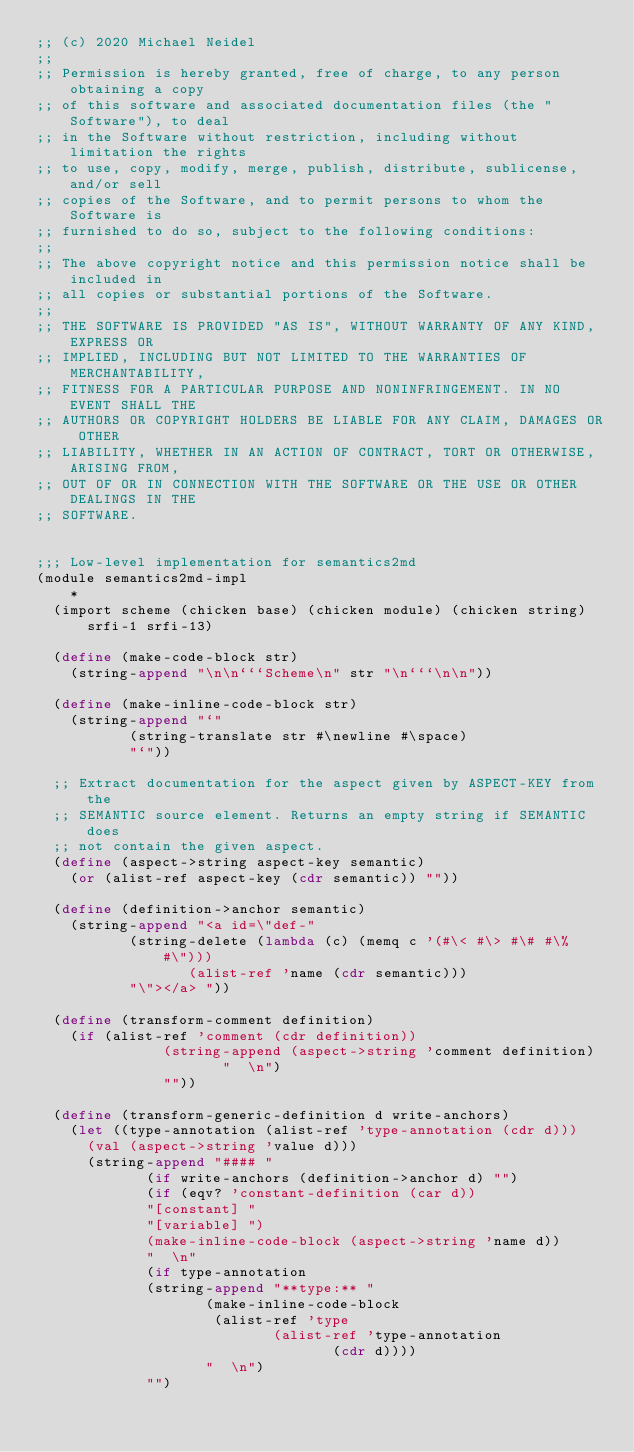<code> <loc_0><loc_0><loc_500><loc_500><_Scheme_>;; (c) 2020 Michael Neidel
;;
;; Permission is hereby granted, free of charge, to any person obtaining a copy
;; of this software and associated documentation files (the "Software"), to deal
;; in the Software without restriction, including without limitation the rights
;; to use, copy, modify, merge, publish, distribute, sublicense, and/or sell
;; copies of the Software, and to permit persons to whom the Software is
;; furnished to do so, subject to the following conditions:
;;
;; The above copyright notice and this permission notice shall be included in
;; all copies or substantial portions of the Software.
;;
;; THE SOFTWARE IS PROVIDED "AS IS", WITHOUT WARRANTY OF ANY KIND, EXPRESS OR
;; IMPLIED, INCLUDING BUT NOT LIMITED TO THE WARRANTIES OF MERCHANTABILITY,
;; FITNESS FOR A PARTICULAR PURPOSE AND NONINFRINGEMENT. IN NO EVENT SHALL THE
;; AUTHORS OR COPYRIGHT HOLDERS BE LIABLE FOR ANY CLAIM, DAMAGES OR OTHER
;; LIABILITY, WHETHER IN AN ACTION OF CONTRACT, TORT OR OTHERWISE, ARISING FROM,
;; OUT OF OR IN CONNECTION WITH THE SOFTWARE OR THE USE OR OTHER DEALINGS IN THE
;; SOFTWARE.


;;; Low-level implementation for semantics2md
(module semantics2md-impl
    *
  (import scheme (chicken base) (chicken module) (chicken string)
	  srfi-1 srfi-13)

  (define (make-code-block str)
    (string-append "\n\n```Scheme\n" str "\n```\n\n"))

  (define (make-inline-code-block str)
    (string-append "`"
		   (string-translate str #\newline #\space)
		   "`"))

  ;; Extract documentation for the aspect given by ASPECT-KEY from the
  ;; SEMANTIC source element. Returns an empty string if SEMANTIC does
  ;; not contain the given aspect.
  (define (aspect->string aspect-key semantic)
    (or (alist-ref aspect-key (cdr semantic)) ""))

  (define (definition->anchor semantic)
    (string-append "<a id=\"def-"
		   (string-delete (lambda (c) (memq c '(#\< #\> #\# #\% #\")))
				  (alist-ref 'name (cdr semantic)))
		   "\"></a> "))

  (define (transform-comment definition)
    (if (alist-ref 'comment (cdr definition))
		       (string-append (aspect->string 'comment definition)
				      "  \n")
		       ""))

  (define (transform-generic-definition d write-anchors)
    (let ((type-annotation (alist-ref 'type-annotation (cdr d)))
	  (val (aspect->string 'value d)))
      (string-append "#### "
		     (if write-anchors (definition->anchor d) "")
		     (if (eqv? 'constant-definition (car d))
			 "[constant] "
			 "[variable] ")
		     (make-inline-code-block (aspect->string 'name d))
		     "  \n"
		     (if type-annotation
			 (string-append "**type:** "
					(make-inline-code-block
					 (alist-ref 'type
						    (alist-ref 'type-annotation
							       (cdr d))))
					"  \n")
			 "")</code> 